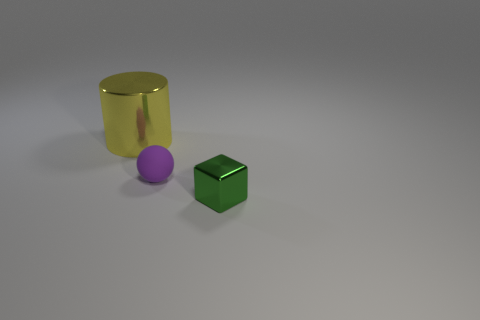Add 1 big cylinders. How many objects exist? 4 Subtract all cylinders. How many objects are left? 2 Subtract all brown cylinders. Subtract all cyan spheres. How many cylinders are left? 1 Subtract all red cubes. How many gray spheres are left? 0 Subtract all purple spheres. Subtract all large cylinders. How many objects are left? 1 Add 3 green things. How many green things are left? 4 Add 1 small green metallic cubes. How many small green metallic cubes exist? 2 Subtract 0 yellow cubes. How many objects are left? 3 